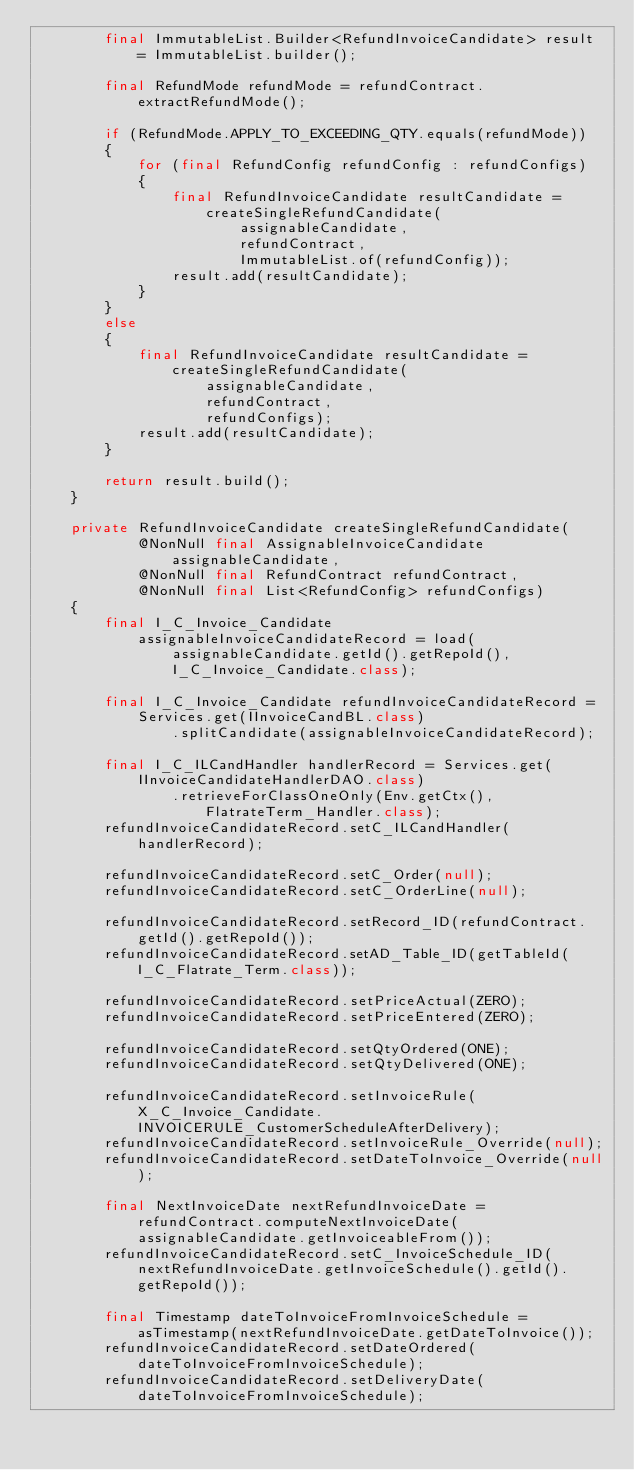Convert code to text. <code><loc_0><loc_0><loc_500><loc_500><_Java_>		final ImmutableList.Builder<RefundInvoiceCandidate> result = ImmutableList.builder();

		final RefundMode refundMode = refundContract.extractRefundMode();

		if (RefundMode.APPLY_TO_EXCEEDING_QTY.equals(refundMode))
		{
			for (final RefundConfig refundConfig : refundConfigs)
			{
				final RefundInvoiceCandidate resultCandidate = createSingleRefundCandidate(
						assignableCandidate,
						refundContract,
						ImmutableList.of(refundConfig));
				result.add(resultCandidate);
			}
		}
		else
		{
			final RefundInvoiceCandidate resultCandidate = createSingleRefundCandidate(
					assignableCandidate,
					refundContract,
					refundConfigs);
			result.add(resultCandidate);
		}

		return result.build();
	}

	private RefundInvoiceCandidate createSingleRefundCandidate(
			@NonNull final AssignableInvoiceCandidate assignableCandidate,
			@NonNull final RefundContract refundContract,
			@NonNull final List<RefundConfig> refundConfigs)
	{
		final I_C_Invoice_Candidate assignableInvoiceCandidateRecord = load(
				assignableCandidate.getId().getRepoId(),
				I_C_Invoice_Candidate.class);

		final I_C_Invoice_Candidate refundInvoiceCandidateRecord = Services.get(IInvoiceCandBL.class)
				.splitCandidate(assignableInvoiceCandidateRecord);

		final I_C_ILCandHandler handlerRecord = Services.get(IInvoiceCandidateHandlerDAO.class)
				.retrieveForClassOneOnly(Env.getCtx(), FlatrateTerm_Handler.class);
		refundInvoiceCandidateRecord.setC_ILCandHandler(handlerRecord);

		refundInvoiceCandidateRecord.setC_Order(null);
		refundInvoiceCandidateRecord.setC_OrderLine(null);

		refundInvoiceCandidateRecord.setRecord_ID(refundContract.getId().getRepoId());
		refundInvoiceCandidateRecord.setAD_Table_ID(getTableId(I_C_Flatrate_Term.class));

		refundInvoiceCandidateRecord.setPriceActual(ZERO);
		refundInvoiceCandidateRecord.setPriceEntered(ZERO);

		refundInvoiceCandidateRecord.setQtyOrdered(ONE);
		refundInvoiceCandidateRecord.setQtyDelivered(ONE);

		refundInvoiceCandidateRecord.setInvoiceRule(X_C_Invoice_Candidate.INVOICERULE_CustomerScheduleAfterDelivery);
		refundInvoiceCandidateRecord.setInvoiceRule_Override(null);
		refundInvoiceCandidateRecord.setDateToInvoice_Override(null);

		final NextInvoiceDate nextRefundInvoiceDate = refundContract.computeNextInvoiceDate(assignableCandidate.getInvoiceableFrom());
		refundInvoiceCandidateRecord.setC_InvoiceSchedule_ID(nextRefundInvoiceDate.getInvoiceSchedule().getId().getRepoId());

		final Timestamp dateToInvoiceFromInvoiceSchedule = asTimestamp(nextRefundInvoiceDate.getDateToInvoice());
		refundInvoiceCandidateRecord.setDateOrdered(dateToInvoiceFromInvoiceSchedule);
		refundInvoiceCandidateRecord.setDeliveryDate(dateToInvoiceFromInvoiceSchedule);
</code> 